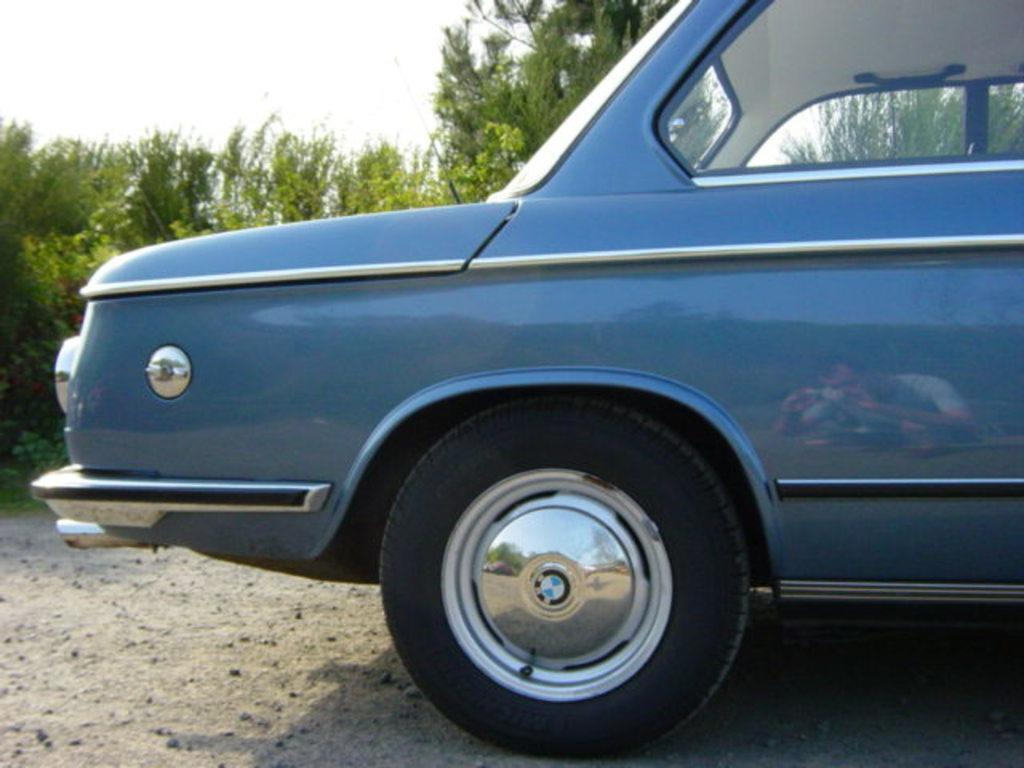In one or two sentences, can you explain what this image depicts? In the image we can see a vehicle, grass, trees, road and a sky. In the reflection we can see a person wearing clothes. 